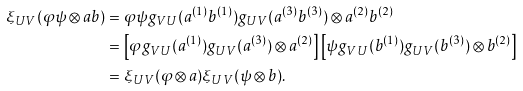Convert formula to latex. <formula><loc_0><loc_0><loc_500><loc_500>\xi _ { U V } ( \varphi \psi \otimes a b ) & = \varphi \psi g _ { V U } ( a ^ { ( 1 ) } b ^ { ( 1 ) } ) g _ { U V } ( a ^ { ( 3 ) } b ^ { ( 3 ) } ) \otimes a ^ { ( 2 ) } b ^ { ( 2 ) } \\ & = \left [ \varphi g _ { V U } ( a ^ { ( 1 ) } ) g _ { U V } ( a ^ { ( 3 ) } ) \otimes a ^ { ( 2 ) } \right ] \left [ \psi g _ { V U } ( b ^ { ( 1 ) } ) g _ { U V } ( b ^ { ( 3 ) } ) \otimes b ^ { ( 2 ) } \right ] \\ & = \xi _ { U V } ( \varphi \otimes a ) \xi _ { U V } ( \psi \otimes b ) .</formula> 